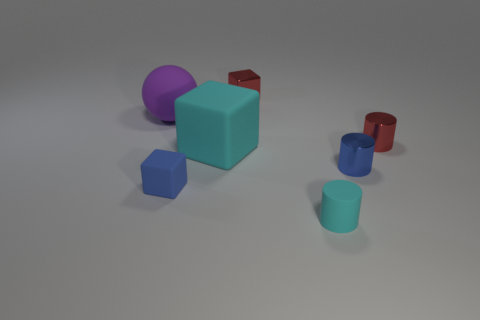There is a cyan rubber thing right of the big cyan object; what is its size?
Your response must be concise. Small. What material is the tiny cylinder to the right of the blue thing on the right side of the cyan cylinder in front of the purple matte object?
Provide a short and direct response. Metal. Is the shape of the big purple thing the same as the blue metal object?
Offer a terse response. No. What number of shiny things are tiny red cylinders or cyan things?
Keep it short and to the point. 1. What number of large balls are there?
Offer a terse response. 1. What color is the object that is the same size as the rubber ball?
Your answer should be very brief. Cyan. Is the cyan rubber cylinder the same size as the red metallic cube?
Ensure brevity in your answer.  Yes. There is a big thing that is the same color as the rubber cylinder; what is its shape?
Your answer should be very brief. Cube. There is a matte cylinder; is its size the same as the red thing that is in front of the purple ball?
Your response must be concise. Yes. What is the color of the thing that is both in front of the blue shiny cylinder and right of the large cyan matte block?
Offer a very short reply. Cyan. 